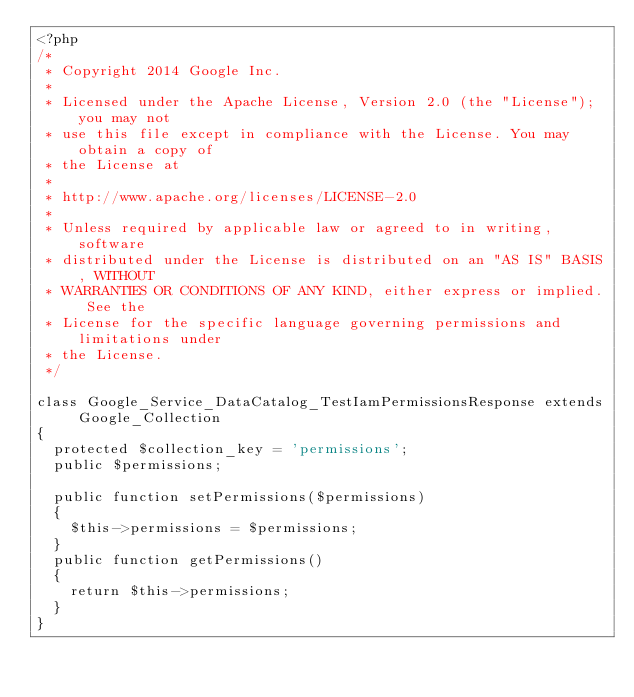<code> <loc_0><loc_0><loc_500><loc_500><_PHP_><?php
/*
 * Copyright 2014 Google Inc.
 *
 * Licensed under the Apache License, Version 2.0 (the "License"); you may not
 * use this file except in compliance with the License. You may obtain a copy of
 * the License at
 *
 * http://www.apache.org/licenses/LICENSE-2.0
 *
 * Unless required by applicable law or agreed to in writing, software
 * distributed under the License is distributed on an "AS IS" BASIS, WITHOUT
 * WARRANTIES OR CONDITIONS OF ANY KIND, either express or implied. See the
 * License for the specific language governing permissions and limitations under
 * the License.
 */

class Google_Service_DataCatalog_TestIamPermissionsResponse extends Google_Collection
{
  protected $collection_key = 'permissions';
  public $permissions;

  public function setPermissions($permissions)
  {
    $this->permissions = $permissions;
  }
  public function getPermissions()
  {
    return $this->permissions;
  }
}
</code> 